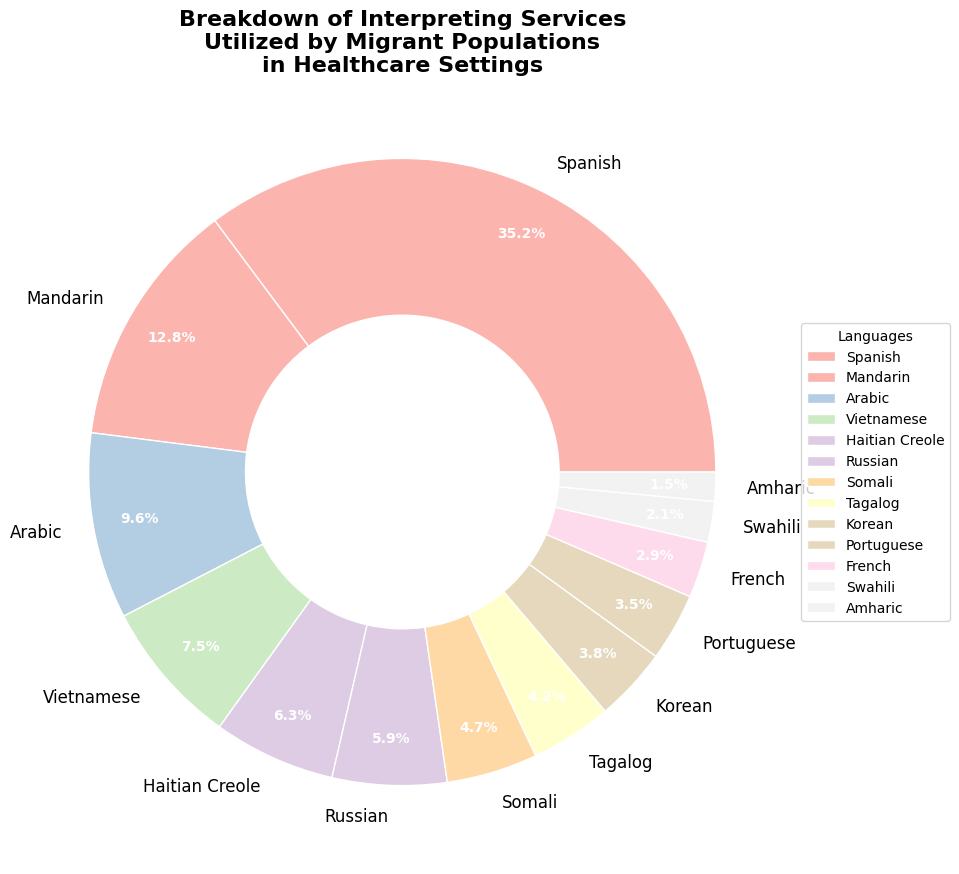What's the most utilized language for interpreting services in healthcare settings? The pie chart shows the percentage for each language. Spanish has the largest percentage at 35.2%, signifying it is the most utilized language.
Answer: Spanish Which language has a higher utilization, Korean or Portuguese? Referring to the pie chart, Korean is listed at 3.8% and Portuguese at 3.5%. Since 3.8% is greater than 3.5%, Korean has a higher utilization than Portuguese.
Answer: Korean What is the combined percentage of interpreting services for Haitian Creole and Russian? Haitian Creole is at 6.3% and Russian is at 5.9%. Adding these together: 6.3% + 5.9% = 12.2%.
Answer: 12.2% How much more utilized is Spanish compared to Mandarin? Spanish has a utilization of 35.2%, and Mandarin is at 12.8%. Subtracting these gives: 35.2% - 12.8% = 22.4%.
Answer: 22.4% Identify two languages that have a utilization of below 5%. Observing the pie chart: Somali (4.7%) and Tagalog (4.2%) are both below 5%.
Answer: Somali and Tagalog What is the least utilized language among the ones listed? The pie chart specifies each language's percentage. Amharic, with 1.5%, has the smallest percentage, making it the least utilized language.
Answer: Amharic How does the combined usage of Arabic and Swahili compare to Spanish? Arabic is at 9.6% and Swahili at 2.1%. Adding these gives: 9.6% + 2.1% = 11.7%. Spanish is 35.2%, and 35.2% is greater than 11.7%, indicating Spanish's usage is higher.
Answer: Spanish is higher If we combine the usage of French and Portuguese, what percentage do they account for? French is at 2.9% and Portuguese is at 3.5%. Adding these gives: 2.9% + 3.5% = 6.4%.
Answer: 6.4% Which languages together cover more than 50% of the utilization? Adding Spanish (35.2%), Mandarin (12.8%), and Arabic (9.6%) gives 35.2% + 12.8% + 9.6% = 57.6%, which is more than 50%.
Answer: Spanish, Mandarin, and Arabic How does the utilization of Haitian Creole (6.3%) compare to Vietnamese (7.5%)? Vietnamese has 7.5% and Haitian Creole has 6.3%. Since 7.5% is greater than 6.3%, Vietnamese is more utilized than Haitian Creole.
Answer: Vietnamese 